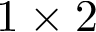<formula> <loc_0><loc_0><loc_500><loc_500>1 \times 2</formula> 